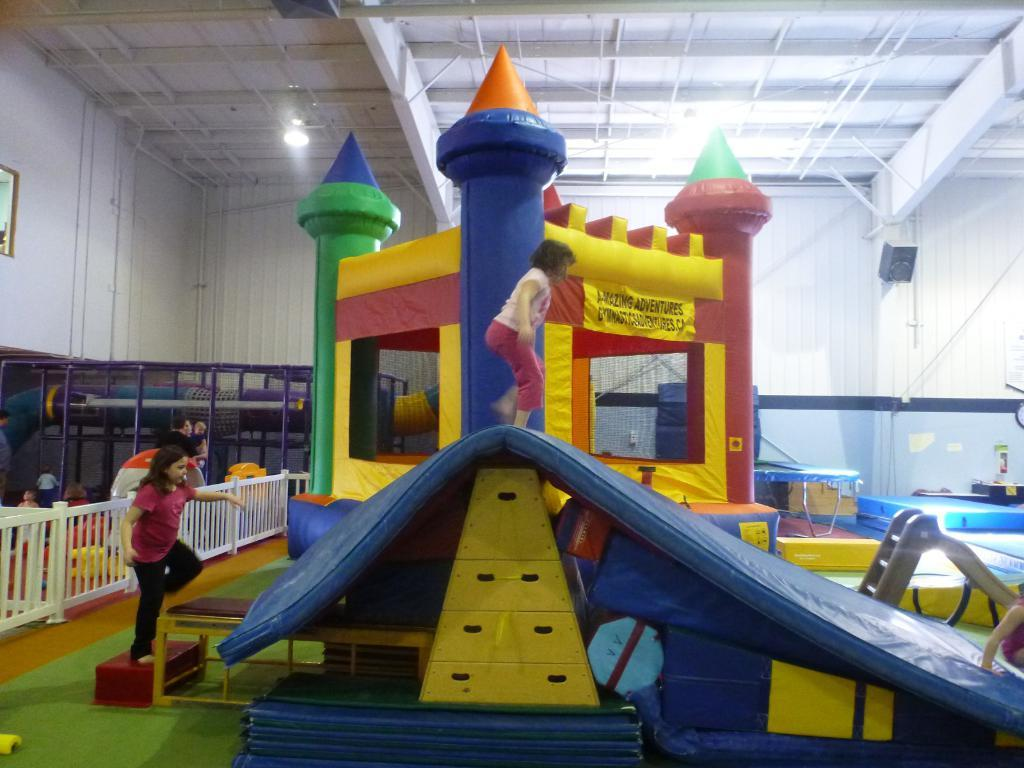What is the main feature in the image? There is a bouncy castle in the image. What can be seen near the bouncy castle? There are children near the bouncy castle. Can you describe the person in the background of the image? There is a person standing in the background of the image. What is visible on the ceiling in the image? There are lights on the ceiling in the image. What type of yoke is being used by the fowl in the image? There are no fowl or yokes present in the image. How many bikes can be seen in the image? There are no bikes present in the image. 